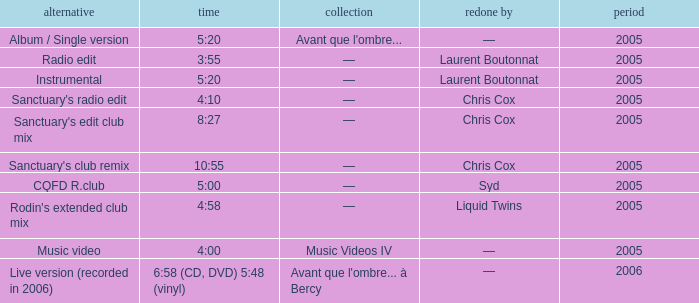What is the version shown for the Length of 5:20, and shows Remixed by —? Album / Single version. 